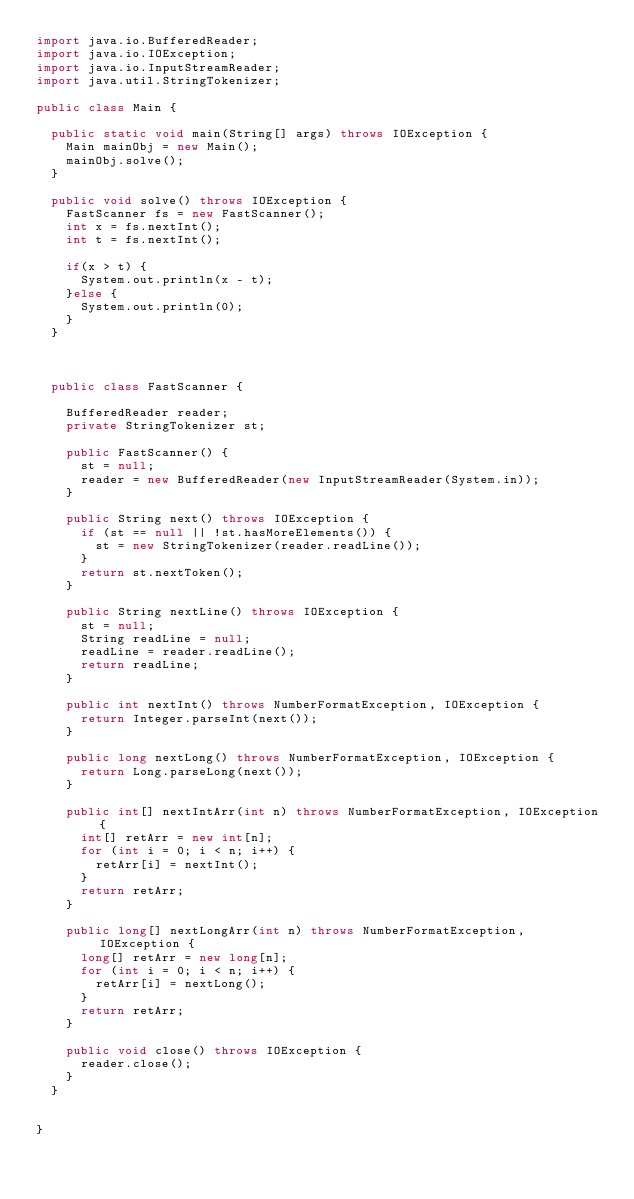<code> <loc_0><loc_0><loc_500><loc_500><_Java_>import java.io.BufferedReader;
import java.io.IOException;
import java.io.InputStreamReader;
import java.util.StringTokenizer;

public class Main {
	
	public static void main(String[] args) throws IOException {
		Main mainObj = new Main();
		mainObj.solve();
	}

	public void solve() throws IOException {
		FastScanner fs = new FastScanner();
		int x = fs.nextInt();
		int t = fs.nextInt();
		
		if(x > t) {
			System.out.println(x - t);
		}else {
			System.out.println(0);
		}
	}

	

	public class FastScanner {

		BufferedReader reader;
		private StringTokenizer st;

		public FastScanner() {
			st = null;
			reader = new BufferedReader(new InputStreamReader(System.in));
		}

		public String next() throws IOException {
			if (st == null || !st.hasMoreElements()) {
				st = new StringTokenizer(reader.readLine());
			}
			return st.nextToken();
		}

		public String nextLine() throws IOException {
			st = null;
			String readLine = null;
			readLine = reader.readLine();
			return readLine;
		}

		public int nextInt() throws NumberFormatException, IOException {
			return Integer.parseInt(next());
		}

		public long nextLong() throws NumberFormatException, IOException {
			return Long.parseLong(next());
		}

		public int[] nextIntArr(int n) throws NumberFormatException, IOException {
			int[] retArr = new int[n];
			for (int i = 0; i < n; i++) {
				retArr[i] = nextInt();
			}
			return retArr;
		}

		public long[] nextLongArr(int n) throws NumberFormatException, IOException {
			long[] retArr = new long[n];
			for (int i = 0; i < n; i++) {
				retArr[i] = nextLong();
			}
			return retArr;
		}

		public void close() throws IOException {
			reader.close();
		}
	}


}
</code> 